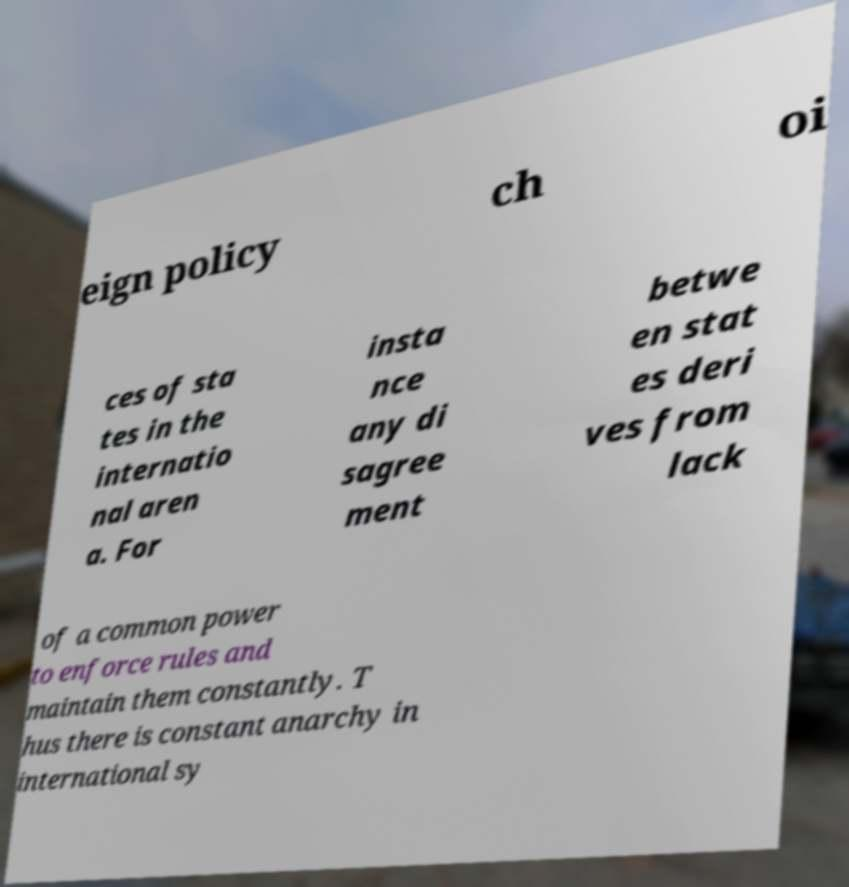Please identify and transcribe the text found in this image. eign policy ch oi ces of sta tes in the internatio nal aren a. For insta nce any di sagree ment betwe en stat es deri ves from lack of a common power to enforce rules and maintain them constantly. T hus there is constant anarchy in international sy 